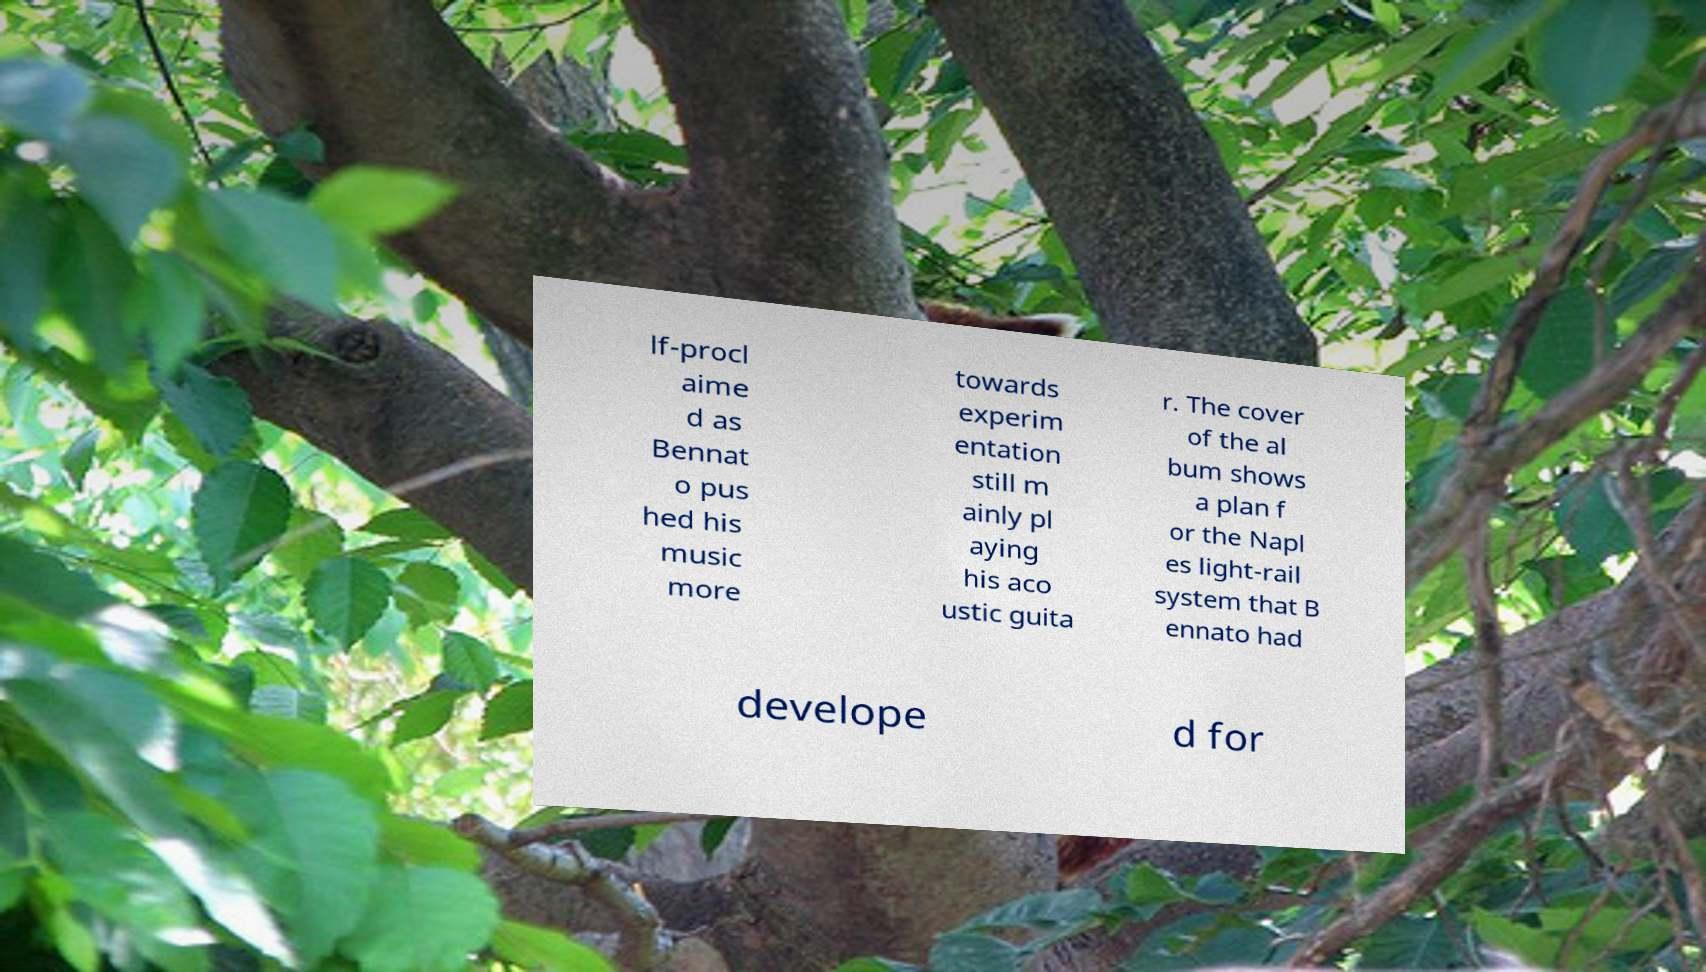Please identify and transcribe the text found in this image. lf-procl aime d as Bennat o pus hed his music more towards experim entation still m ainly pl aying his aco ustic guita r. The cover of the al bum shows a plan f or the Napl es light-rail system that B ennato had develope d for 